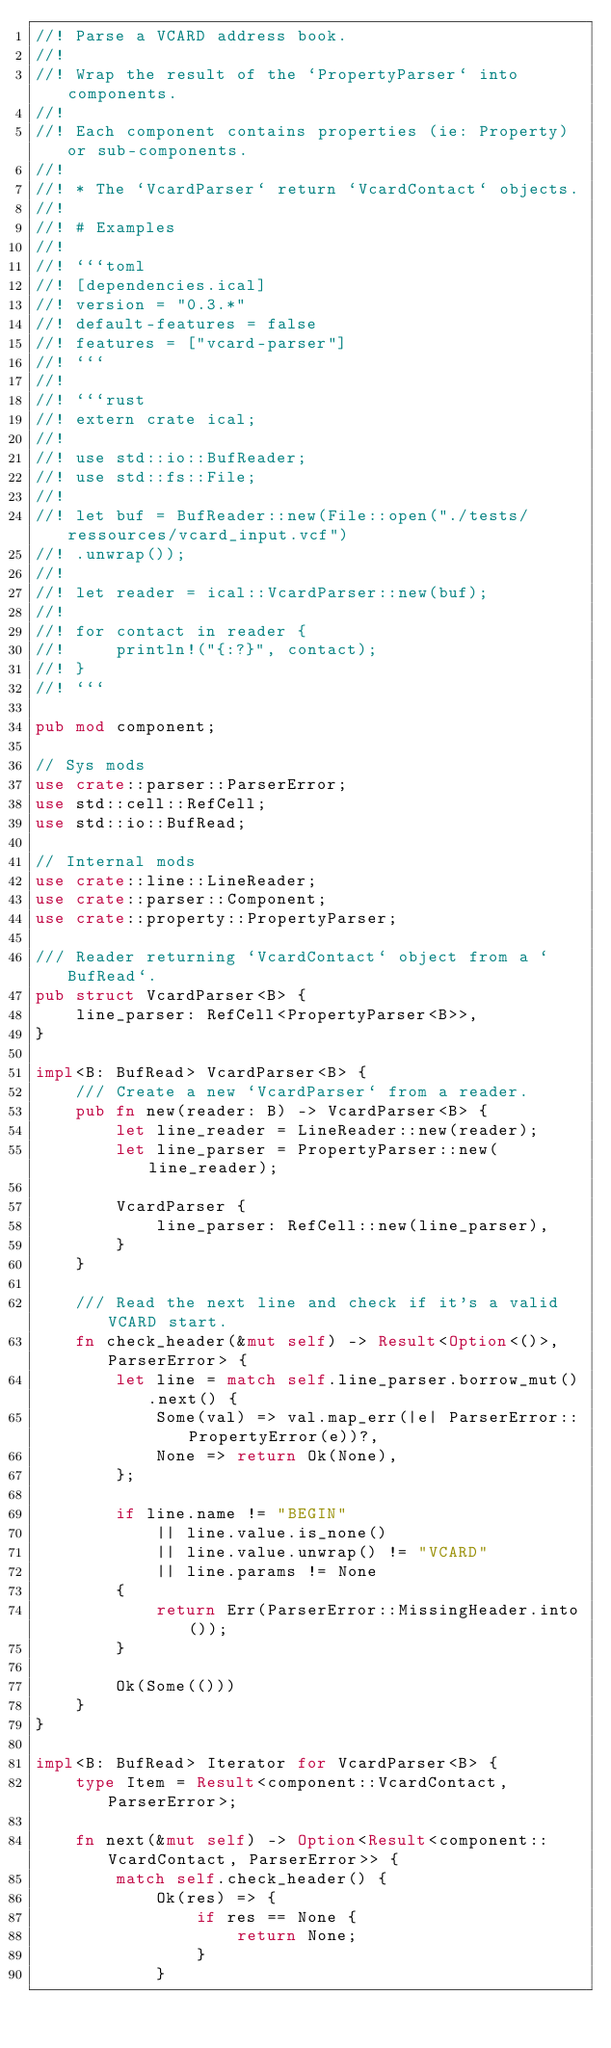Convert code to text. <code><loc_0><loc_0><loc_500><loc_500><_Rust_>//! Parse a VCARD address book.
//!
//! Wrap the result of the `PropertyParser` into components.
//!
//! Each component contains properties (ie: Property) or sub-components.
//!
//! * The `VcardParser` return `VcardContact` objects.
//!
//! # Examples
//!
//! ```toml
//! [dependencies.ical]
//! version = "0.3.*"
//! default-features = false
//! features = ["vcard-parser"]
//! ```
//!
//! ```rust
//! extern crate ical;
//!
//! use std::io::BufReader;
//! use std::fs::File;
//!
//! let buf = BufReader::new(File::open("./tests/ressources/vcard_input.vcf")
//! .unwrap());
//!
//! let reader = ical::VcardParser::new(buf);
//!
//! for contact in reader {
//!     println!("{:?}", contact);
//! }
//! ```

pub mod component;

// Sys mods
use crate::parser::ParserError;
use std::cell::RefCell;
use std::io::BufRead;

// Internal mods
use crate::line::LineReader;
use crate::parser::Component;
use crate::property::PropertyParser;

/// Reader returning `VcardContact` object from a `BufRead`.
pub struct VcardParser<B> {
    line_parser: RefCell<PropertyParser<B>>,
}

impl<B: BufRead> VcardParser<B> {
    /// Create a new `VcardParser` from a reader.
    pub fn new(reader: B) -> VcardParser<B> {
        let line_reader = LineReader::new(reader);
        let line_parser = PropertyParser::new(line_reader);

        VcardParser {
            line_parser: RefCell::new(line_parser),
        }
    }

    /// Read the next line and check if it's a valid VCARD start.
    fn check_header(&mut self) -> Result<Option<()>, ParserError> {
        let line = match self.line_parser.borrow_mut().next() {
            Some(val) => val.map_err(|e| ParserError::PropertyError(e))?,
            None => return Ok(None),
        };

        if line.name != "BEGIN"
            || line.value.is_none()
            || line.value.unwrap() != "VCARD"
            || line.params != None
        {
            return Err(ParserError::MissingHeader.into());
        }

        Ok(Some(()))
    }
}

impl<B: BufRead> Iterator for VcardParser<B> {
    type Item = Result<component::VcardContact, ParserError>;

    fn next(&mut self) -> Option<Result<component::VcardContact, ParserError>> {
        match self.check_header() {
            Ok(res) => {
                if res == None {
                    return None;
                }
            }</code> 